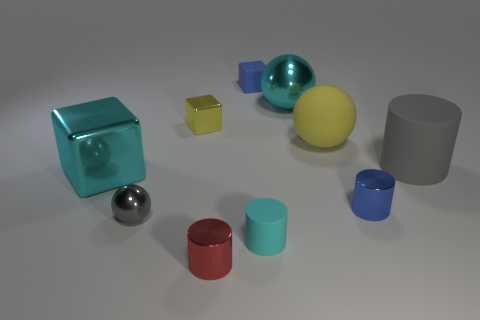Do the large matte thing on the right side of the small blue metallic object and the tiny gray thing have the same shape?
Your answer should be very brief. No. What shape is the small matte thing that is behind the big thing left of the gray sphere left of the yellow shiny thing?
Offer a terse response. Cube. There is a thing that is in front of the cyan matte cylinder; what is its material?
Your response must be concise. Metal. The metal ball that is the same size as the red cylinder is what color?
Your answer should be compact. Gray. What number of other things are there of the same shape as the tiny red thing?
Your answer should be very brief. 3. Is the yellow shiny object the same size as the gray rubber cylinder?
Provide a succinct answer. No. Are there more tiny cylinders that are on the right side of the large metallic sphere than things left of the large matte cylinder?
Offer a very short reply. No. What number of other objects are there of the same size as the yellow matte ball?
Provide a succinct answer. 3. There is a sphere that is in front of the rubber sphere; is its color the same as the rubber ball?
Make the answer very short. No. Are there more things to the left of the small cyan thing than blue rubber spheres?
Your response must be concise. Yes. 